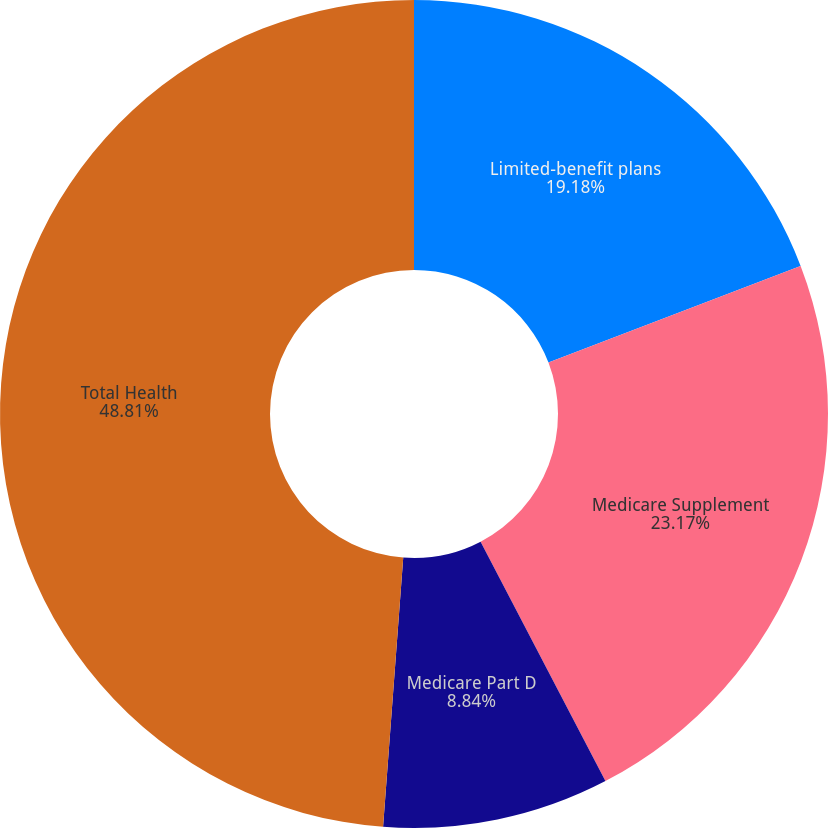Convert chart. <chart><loc_0><loc_0><loc_500><loc_500><pie_chart><fcel>Limited-benefit plans<fcel>Medicare Supplement<fcel>Medicare Part D<fcel>Total Health<nl><fcel>19.18%<fcel>23.17%<fcel>8.84%<fcel>48.81%<nl></chart> 